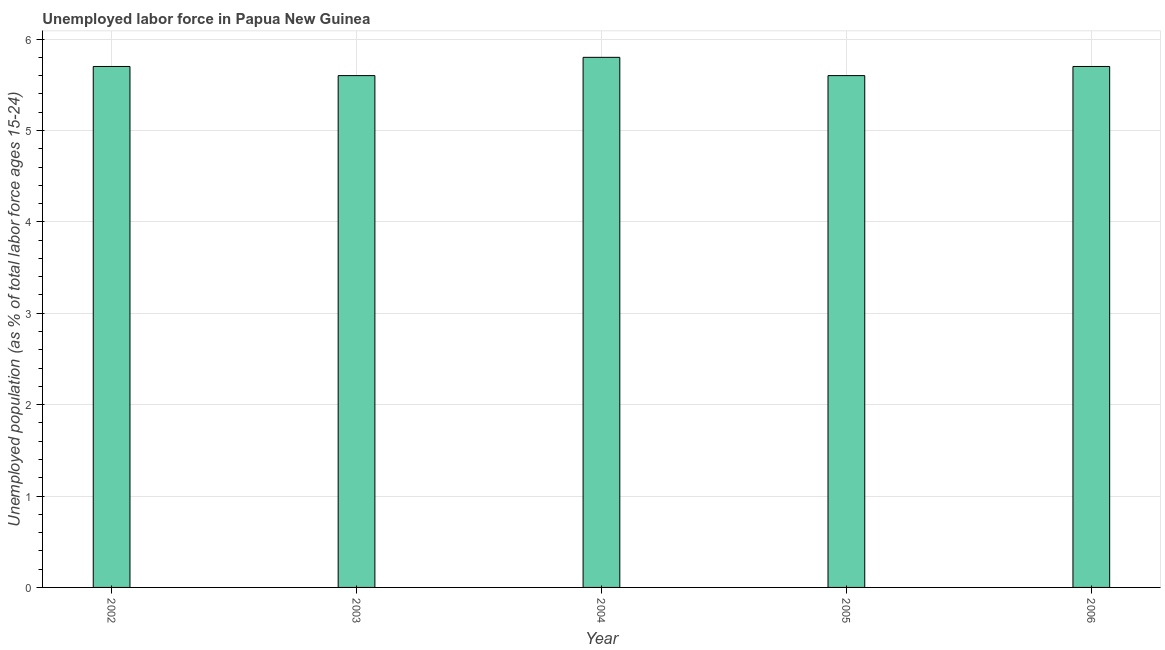Does the graph contain any zero values?
Your answer should be very brief. No. Does the graph contain grids?
Your answer should be very brief. Yes. What is the title of the graph?
Keep it short and to the point. Unemployed labor force in Papua New Guinea. What is the label or title of the X-axis?
Your response must be concise. Year. What is the label or title of the Y-axis?
Your answer should be compact. Unemployed population (as % of total labor force ages 15-24). What is the total unemployed youth population in 2006?
Keep it short and to the point. 5.7. Across all years, what is the maximum total unemployed youth population?
Provide a short and direct response. 5.8. Across all years, what is the minimum total unemployed youth population?
Offer a terse response. 5.6. In which year was the total unemployed youth population maximum?
Your response must be concise. 2004. In which year was the total unemployed youth population minimum?
Your response must be concise. 2003. What is the sum of the total unemployed youth population?
Provide a succinct answer. 28.4. What is the difference between the total unemployed youth population in 2002 and 2006?
Offer a very short reply. 0. What is the average total unemployed youth population per year?
Your answer should be compact. 5.68. What is the median total unemployed youth population?
Your answer should be compact. 5.7. In how many years, is the total unemployed youth population greater than 1.2 %?
Offer a very short reply. 5. Do a majority of the years between 2003 and 2006 (inclusive) have total unemployed youth population greater than 2.8 %?
Give a very brief answer. Yes. What is the ratio of the total unemployed youth population in 2004 to that in 2005?
Your answer should be very brief. 1.04. What is the difference between the highest and the second highest total unemployed youth population?
Ensure brevity in your answer.  0.1. Is the sum of the total unemployed youth population in 2005 and 2006 greater than the maximum total unemployed youth population across all years?
Offer a terse response. Yes. What is the difference between the highest and the lowest total unemployed youth population?
Give a very brief answer. 0.2. How many bars are there?
Give a very brief answer. 5. Are all the bars in the graph horizontal?
Your response must be concise. No. Are the values on the major ticks of Y-axis written in scientific E-notation?
Ensure brevity in your answer.  No. What is the Unemployed population (as % of total labor force ages 15-24) of 2002?
Ensure brevity in your answer.  5.7. What is the Unemployed population (as % of total labor force ages 15-24) of 2003?
Offer a terse response. 5.6. What is the Unemployed population (as % of total labor force ages 15-24) of 2004?
Provide a short and direct response. 5.8. What is the Unemployed population (as % of total labor force ages 15-24) in 2005?
Provide a succinct answer. 5.6. What is the Unemployed population (as % of total labor force ages 15-24) of 2006?
Provide a succinct answer. 5.7. What is the difference between the Unemployed population (as % of total labor force ages 15-24) in 2002 and 2004?
Offer a terse response. -0.1. What is the difference between the Unemployed population (as % of total labor force ages 15-24) in 2002 and 2006?
Keep it short and to the point. 0. What is the difference between the Unemployed population (as % of total labor force ages 15-24) in 2004 and 2005?
Your answer should be compact. 0.2. What is the ratio of the Unemployed population (as % of total labor force ages 15-24) in 2002 to that in 2003?
Your answer should be very brief. 1.02. What is the ratio of the Unemployed population (as % of total labor force ages 15-24) in 2002 to that in 2006?
Keep it short and to the point. 1. What is the ratio of the Unemployed population (as % of total labor force ages 15-24) in 2003 to that in 2006?
Give a very brief answer. 0.98. What is the ratio of the Unemployed population (as % of total labor force ages 15-24) in 2004 to that in 2005?
Ensure brevity in your answer.  1.04. 